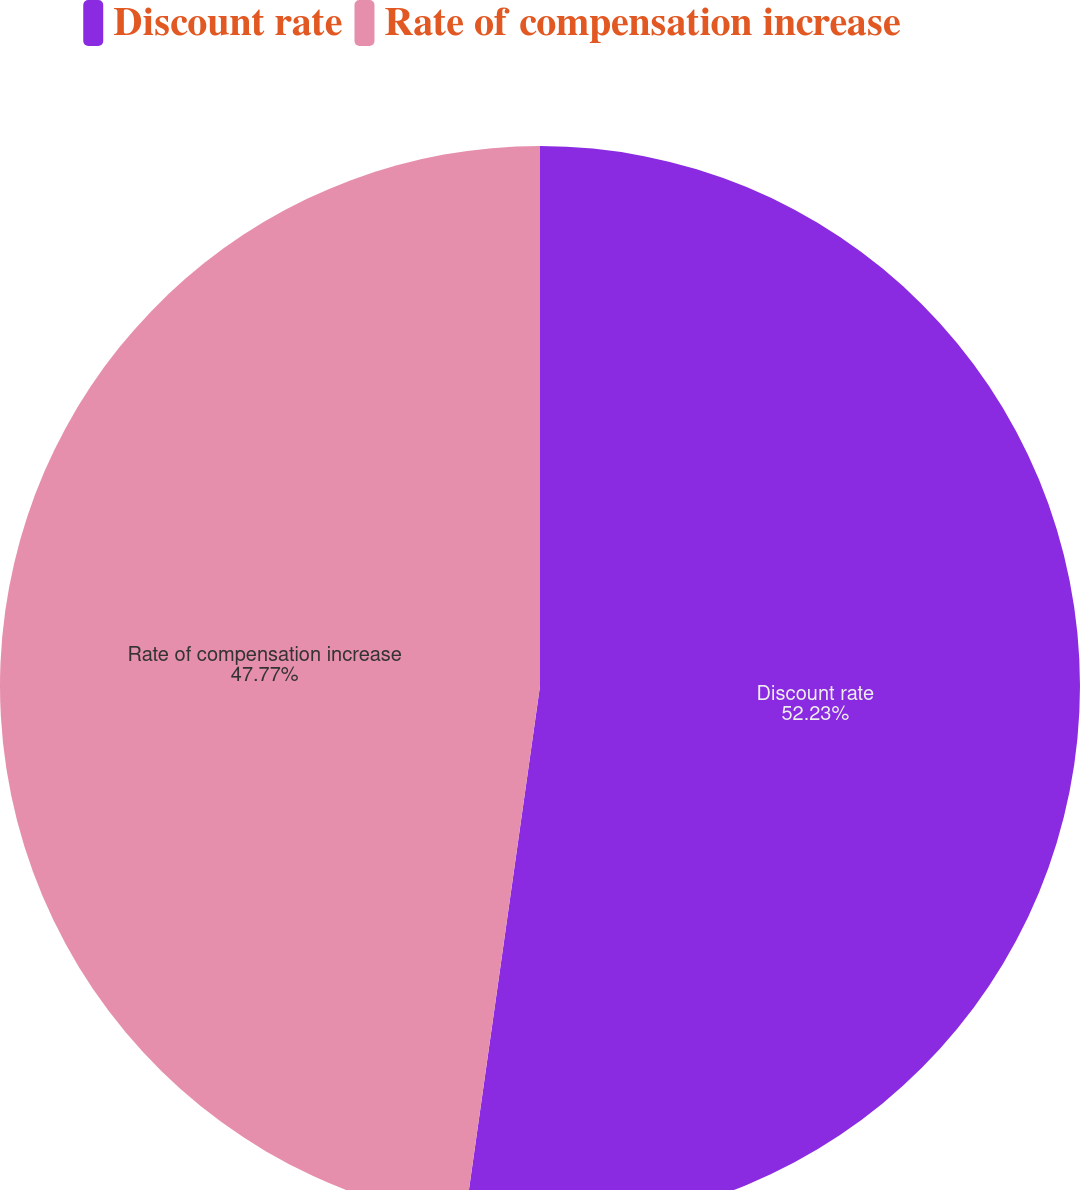Convert chart to OTSL. <chart><loc_0><loc_0><loc_500><loc_500><pie_chart><fcel>Discount rate<fcel>Rate of compensation increase<nl><fcel>52.23%<fcel>47.77%<nl></chart> 